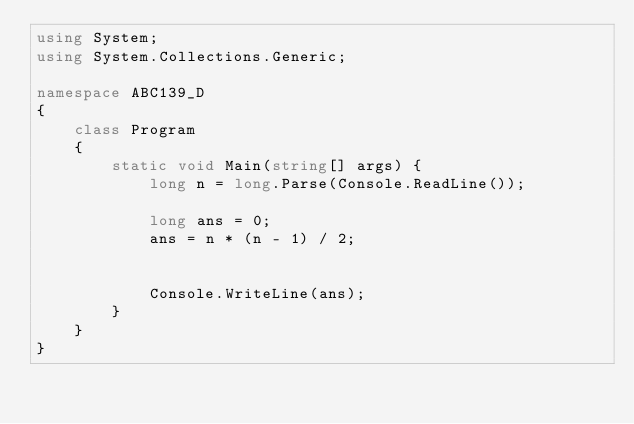Convert code to text. <code><loc_0><loc_0><loc_500><loc_500><_C#_>using System;
using System.Collections.Generic;

namespace ABC139_D
{
    class Program
    {
        static void Main(string[] args) {
            long n = long.Parse(Console.ReadLine());

            long ans = 0;
            ans = n * (n - 1) / 2;

            
            Console.WriteLine(ans);
        }
    }
}</code> 